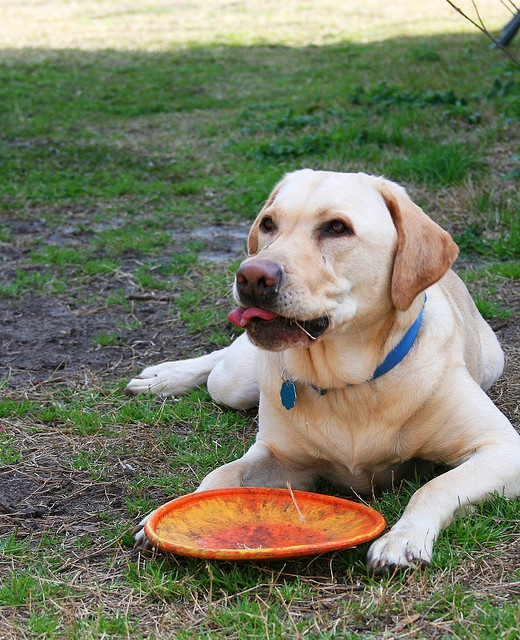Describe the objects in this image and their specific colors. I can see dog in ivory, lightgray, darkgray, and tan tones and frisbee in ivory, red, orange, and salmon tones in this image. 